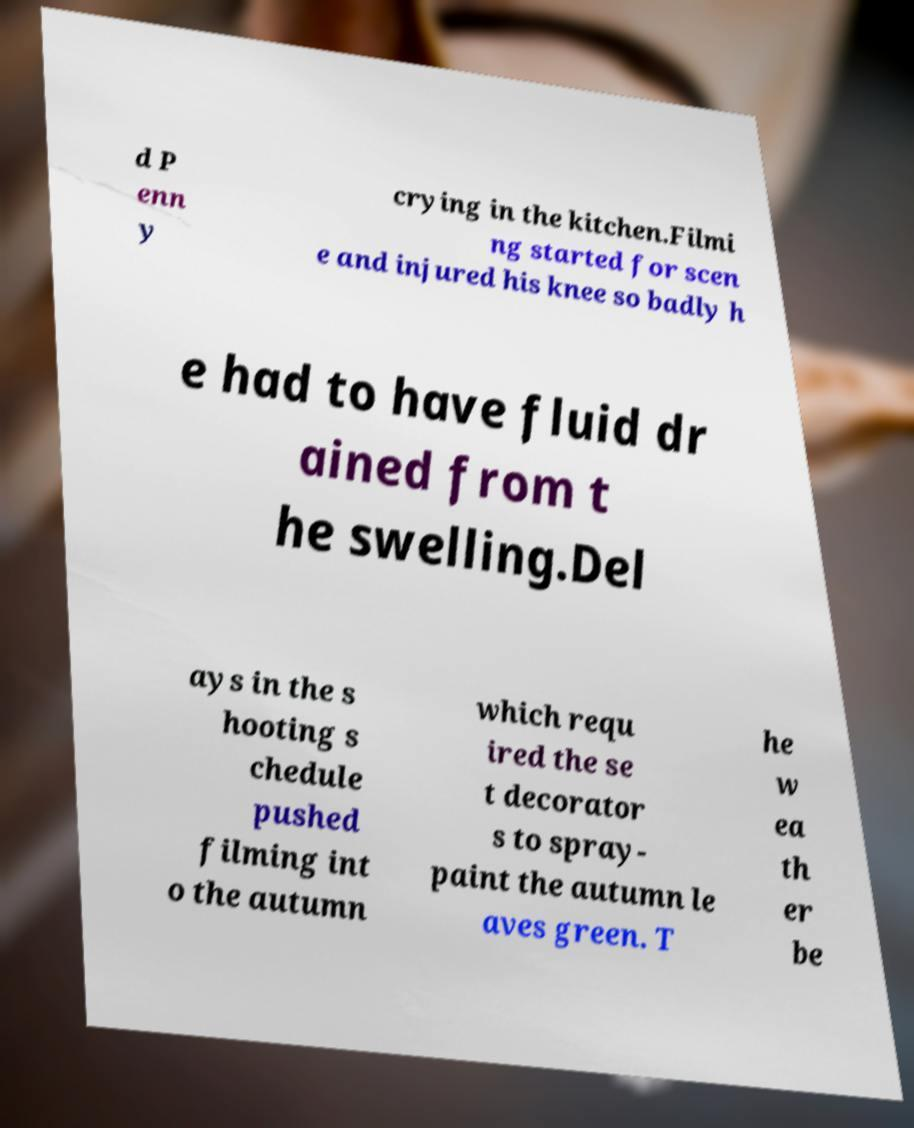Please read and relay the text visible in this image. What does it say? d P enn y crying in the kitchen.Filmi ng started for scen e and injured his knee so badly h e had to have fluid dr ained from t he swelling.Del ays in the s hooting s chedule pushed filming int o the autumn which requ ired the se t decorator s to spray- paint the autumn le aves green. T he w ea th er be 